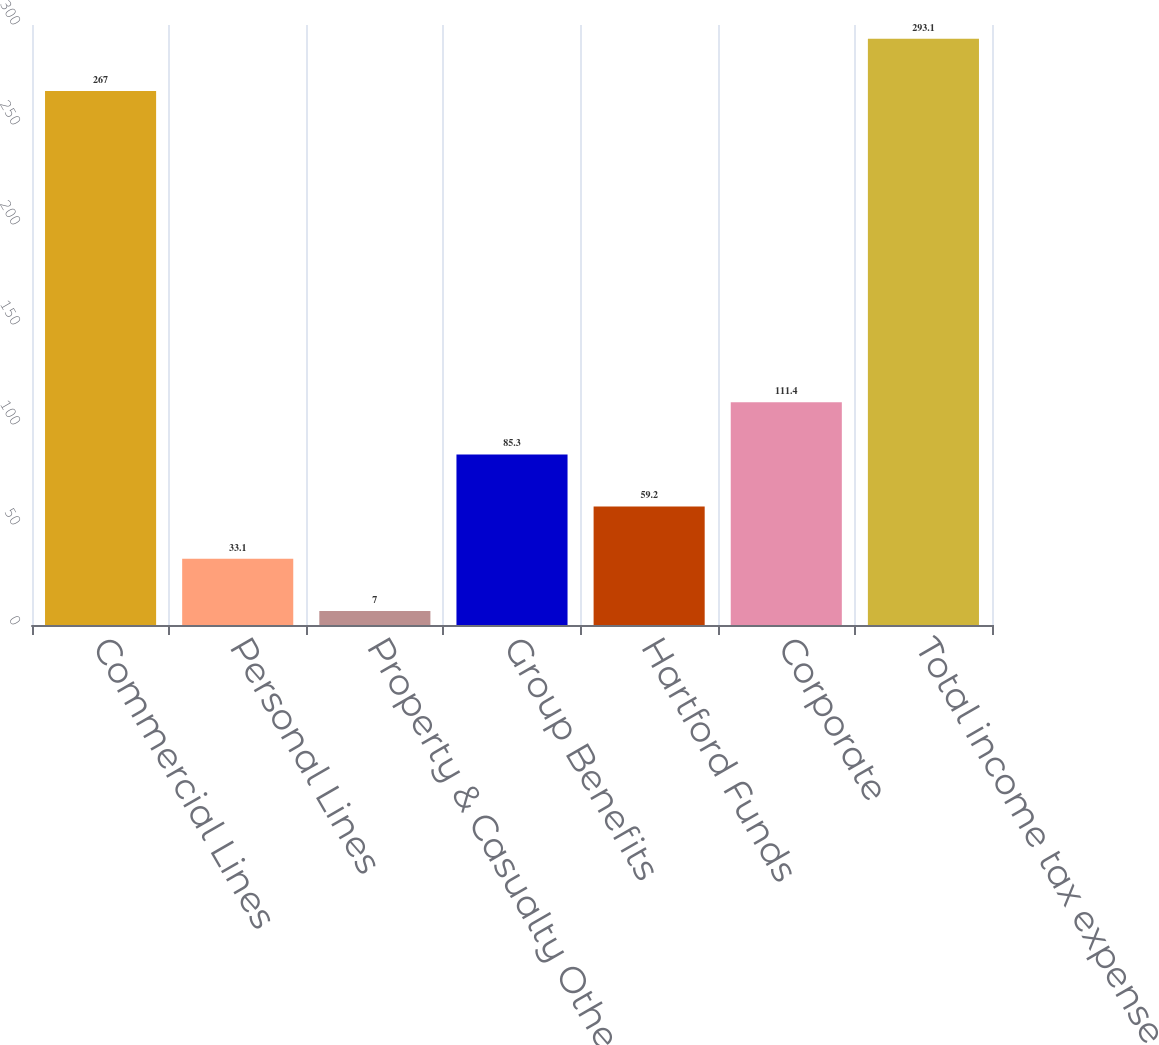Convert chart to OTSL. <chart><loc_0><loc_0><loc_500><loc_500><bar_chart><fcel>Commercial Lines<fcel>Personal Lines<fcel>Property & Casualty Other<fcel>Group Benefits<fcel>Hartford Funds<fcel>Corporate<fcel>Total income tax expense<nl><fcel>267<fcel>33.1<fcel>7<fcel>85.3<fcel>59.2<fcel>111.4<fcel>293.1<nl></chart> 